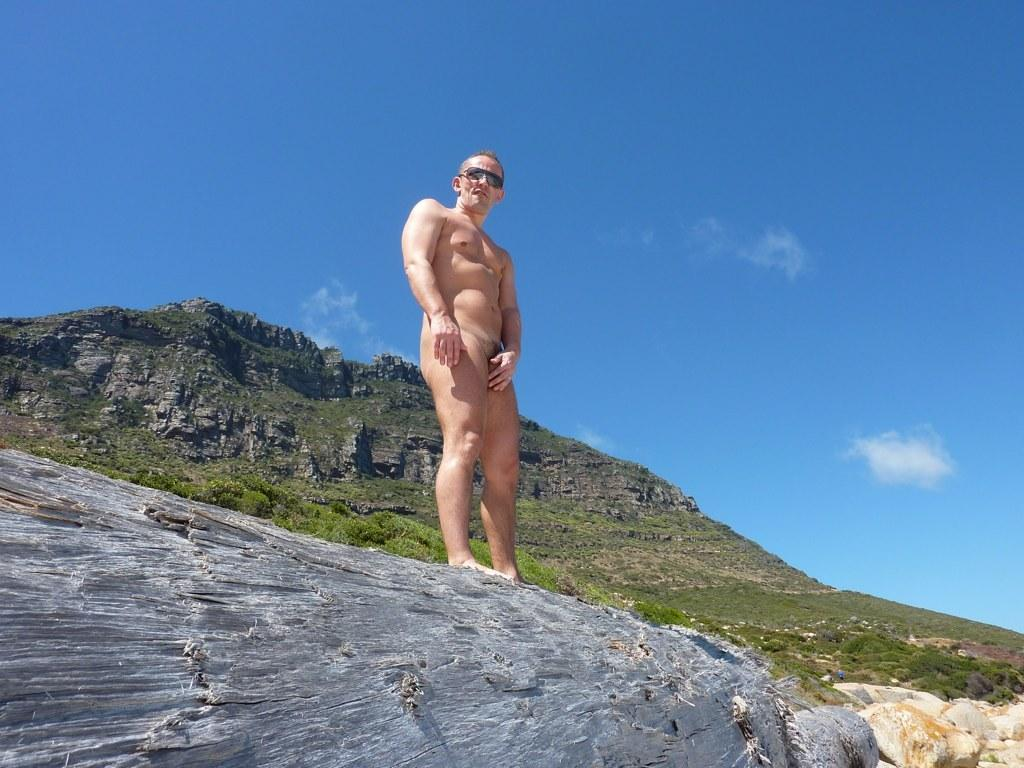What is the person in the image doing? The person is standing on a rock in the image. Which side of the rock is the person standing on? The person is standing on the back side of the rock. What other geographical feature can be seen in the image? There is a hill visible in the image. What type of oil can be seen dripping from the flowers in the image? There are no flowers or oil present in the image; it features a person standing on a rock with a hill in the background. 